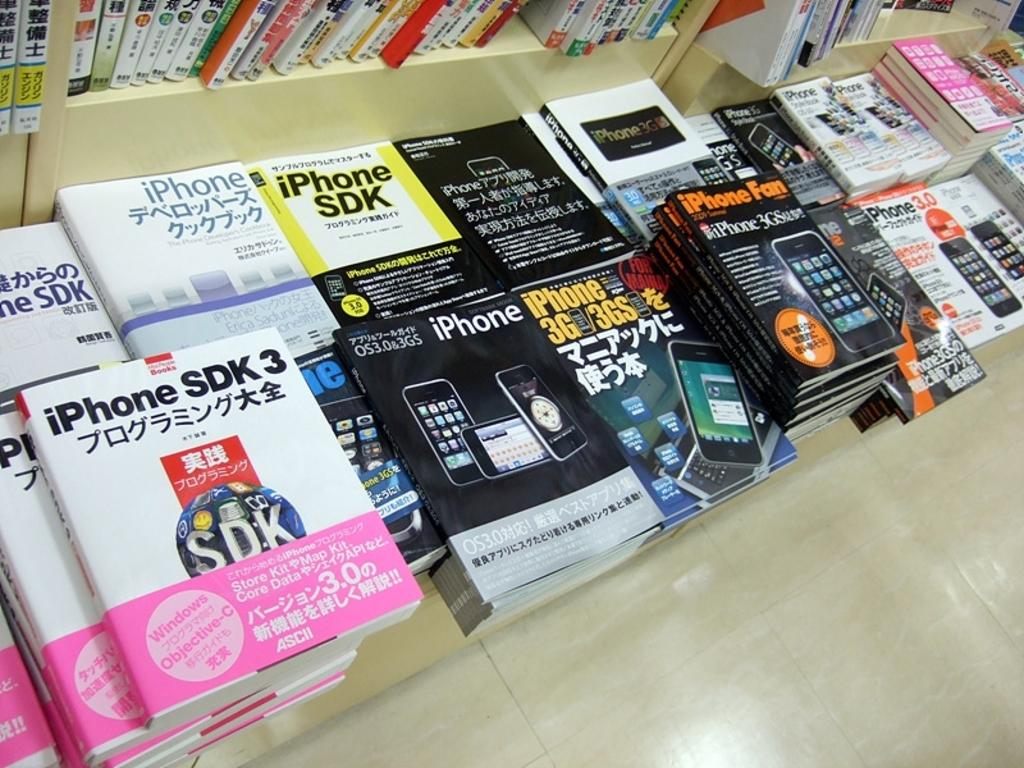<image>
Summarize the visual content of the image. Different iPhone books in a book store stacked on the floor. 